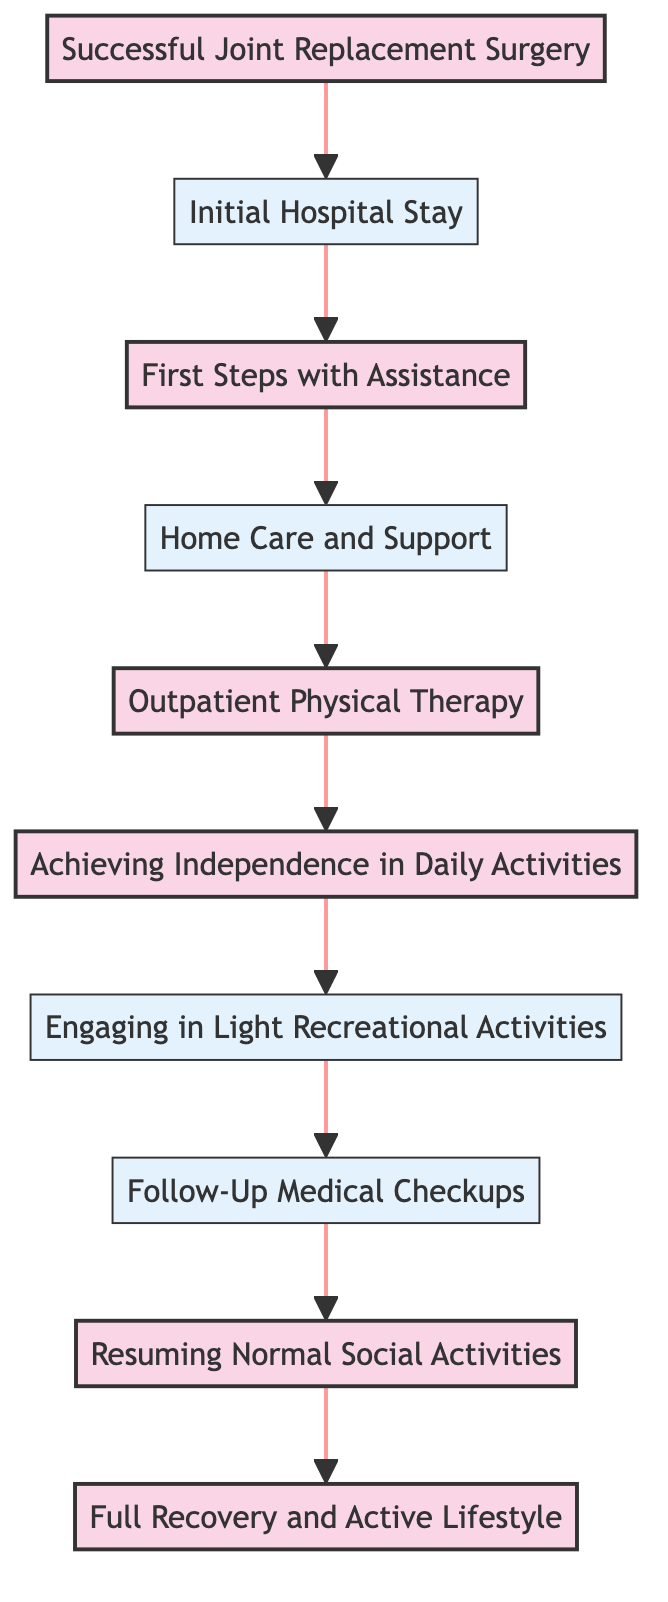What is the first milestone in the recovery journey? The first milestone in the recovery journey is "Successful Joint Replacement Surgery." This is indicated at the bottom of the flow chart and is the starting point of the recovery timeline.
Answer: Successful Joint Replacement Surgery How many milestones are in this recovery journey? By looking at the flowchart, we can count the milestones marked in the diagram. There are 6 milestones: Successful Joint Replacement Surgery, First Steps with Assistance, Outpatient Physical Therapy, Achieving Independence in Daily Activities, Resuming Normal Social Activities, and Full Recovery and Active Lifestyle.
Answer: 6 What follows the "First Steps with Assistance" node? The node that follows "First Steps with Assistance" is "Home Care and Support." This can be seen directly above it in the flow direction of the chart.
Answer: Home Care and Support What is the last milestone described in this journey? The last milestone in the flow chart is "Full Recovery and Active Lifestyle," which is at the top of the diagram, indicating it is the final achievement in this recovery process.
Answer: Full Recovery and Active Lifestyle Which activity is shown after "Engaging in Light Recreational Activities"? The activity shown after "Engaging in Light Recreational Activities" is "Follow-Up Medical Checkups." This is identified as the next node in the upward flow of the chart.
Answer: Follow-Up Medical Checkups Which milestone occurs before achieving independence in daily activities? The milestone that occurs before achieving independence in daily activities is "Outpatient Physical Therapy." This can be traced upward from the "Achieving Independence in Daily Activities" node in the flow of the chart.
Answer: Outpatient Physical Therapy How does the journey start according to the diagram? The journey starts with "Successful Joint Replacement Surgery." This is the first element in the flowchart and marks the beginning of the recovery process.
Answer: Successful Joint Replacement Surgery What type of activities can be engaged in before reaching full recovery? Before reaching full recovery, the activities that can be engaged in include "Engaging in Light Recreational Activities" and "Follow-Up Medical Checkups," which are both indicated before reaching the final milestone in the diagram.
Answer: Engaging in Light Recreational Activities, Follow-Up Medical Checkups 